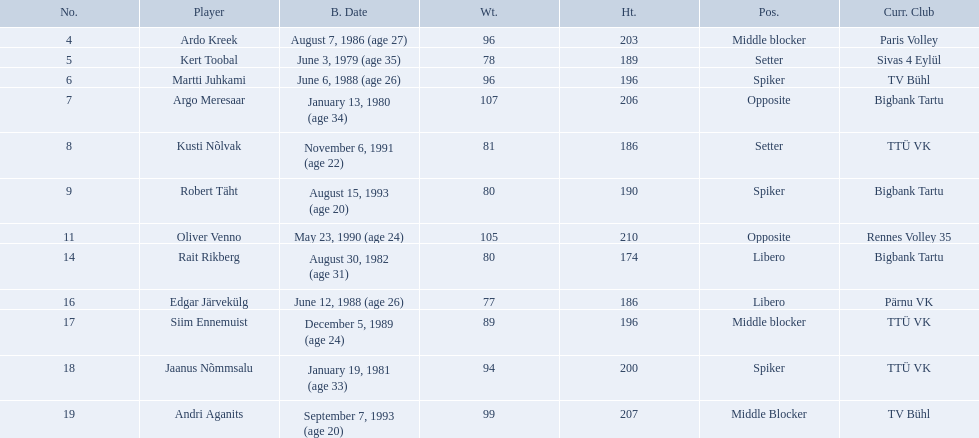Who are all of the players? Ardo Kreek, Kert Toobal, Martti Juhkami, Argo Meresaar, Kusti Nõlvak, Robert Täht, Oliver Venno, Rait Rikberg, Edgar Järvekülg, Siim Ennemuist, Jaanus Nõmmsalu, Andri Aganits. How tall are they? 203, 189, 196, 206, 186, 190, 210, 174, 186, 196, 200, 207. And which player is tallest? Oliver Venno. 